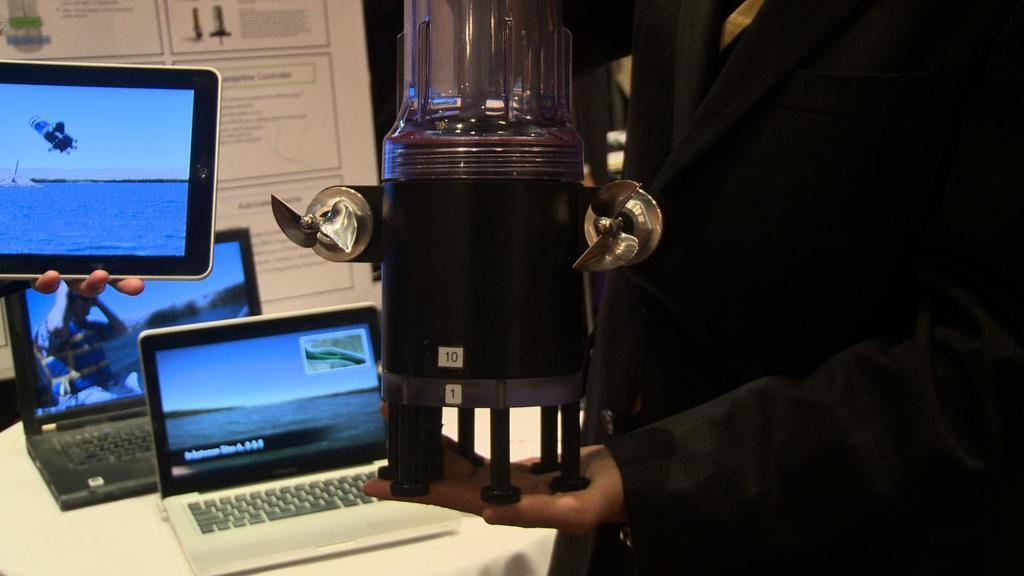<image>
Describe the image concisely. A series of small netbooks, one of them a Dell on a table. 